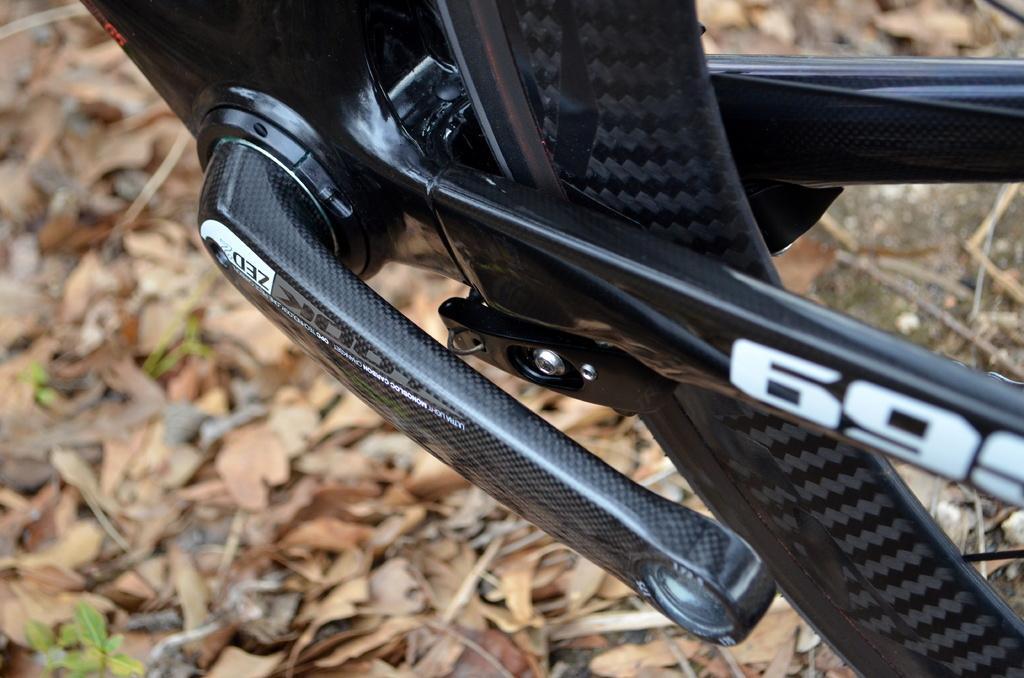In one or two sentences, can you explain what this image depicts? In this image there is the bottom part of the vehicle. There are dried leaves and small plants on the vehicle. 